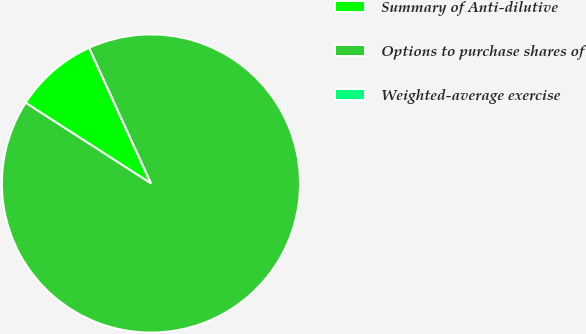Convert chart to OTSL. <chart><loc_0><loc_0><loc_500><loc_500><pie_chart><fcel>Summary of Anti-dilutive<fcel>Options to purchase shares of<fcel>Weighted-average exercise<nl><fcel>9.09%<fcel>90.9%<fcel>0.0%<nl></chart> 